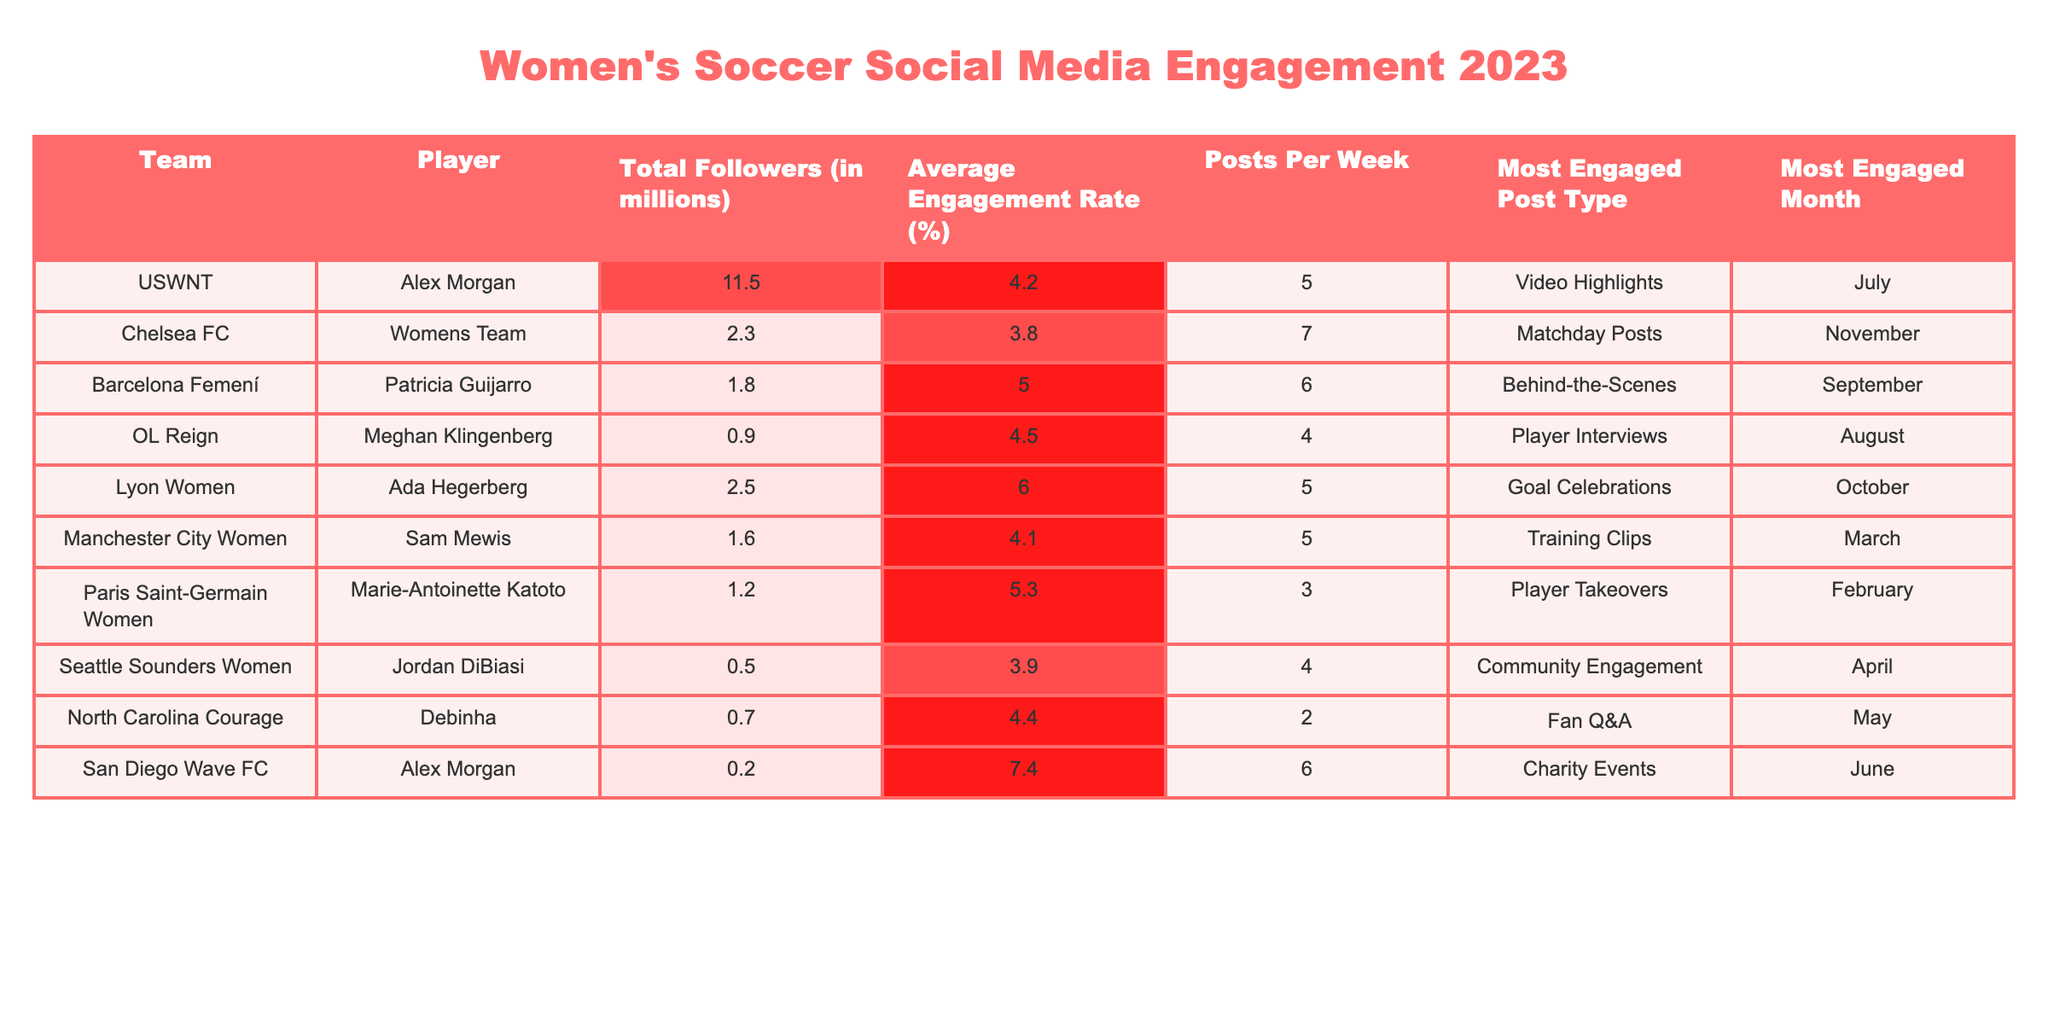What is the total number of followers for Alex Morgan? The table shows that Alex Morgan, under the USWNT, has a total of 11.5 million followers.
Answer: 11.5 million Which player has the highest average engagement rate? Ada Hegerberg, playing for Lyon Women, has the highest average engagement rate of 6.0%.
Answer: 6.0% How many posts per week does the Chelsea FC women's team make? The table indicates that Chelsea FC's women's team posts an average of 7 times per week.
Answer: 7 What is the most engaged post type for Patricia Guijarro? Patricia Guijarro's most engaged post type is "Behind-the-Scenes," as specified in the corresponding row of the table.
Answer: Behind-the-Scenes Is Marie-Antoinette Katoto's average engagement rate higher than Sam Mewis's? Yes, Marie-Antoinette Katoto has an engagement rate of 5.3%, while Sam Mewis has an engagement rate of 4.1%, which means Katoto's rate is higher.
Answer: Yes What is the average total followers (in millions) of all players listed in the table? To find the average, we sum the total followers: 11.5 + 2.3 + 1.8 + 0.9 + 2.5 + 1.6 + 1.2 + 0.5 + 0.7 + 0.2 = 22.8 million. There are 10 players, so the average is 22.8 million / 10 = 2.28 million.
Answer: 2.28 million Which team has the least number of followers? The Seattle Sounders Women have the least number of followers at 0.5 million compared to other teams listed in the table.
Answer: Seattle Sounders Women In which month was the most engaged post type for the USWNT? According to the table, the most engaged post type for the USWNT is "Video Highlights," which occurred in July.
Answer: July What is the combined average engagement rate for the players from Lyon Women and OL Reign? To calculate, first sum their engagement rates: 6.0 (Lyon) + 4.5 (OL Reign) = 10.5. Then, divide by 2 (for the two players): 10.5 / 2 = 5.25%.
Answer: 5.25% Which player had community engagement as their most engaged post type? Jordan DiBiasi from the Seattle Sounders Women had "Community Engagement" as her most engaged post type as mentioned in her row.
Answer: Jordan DiBiasi 